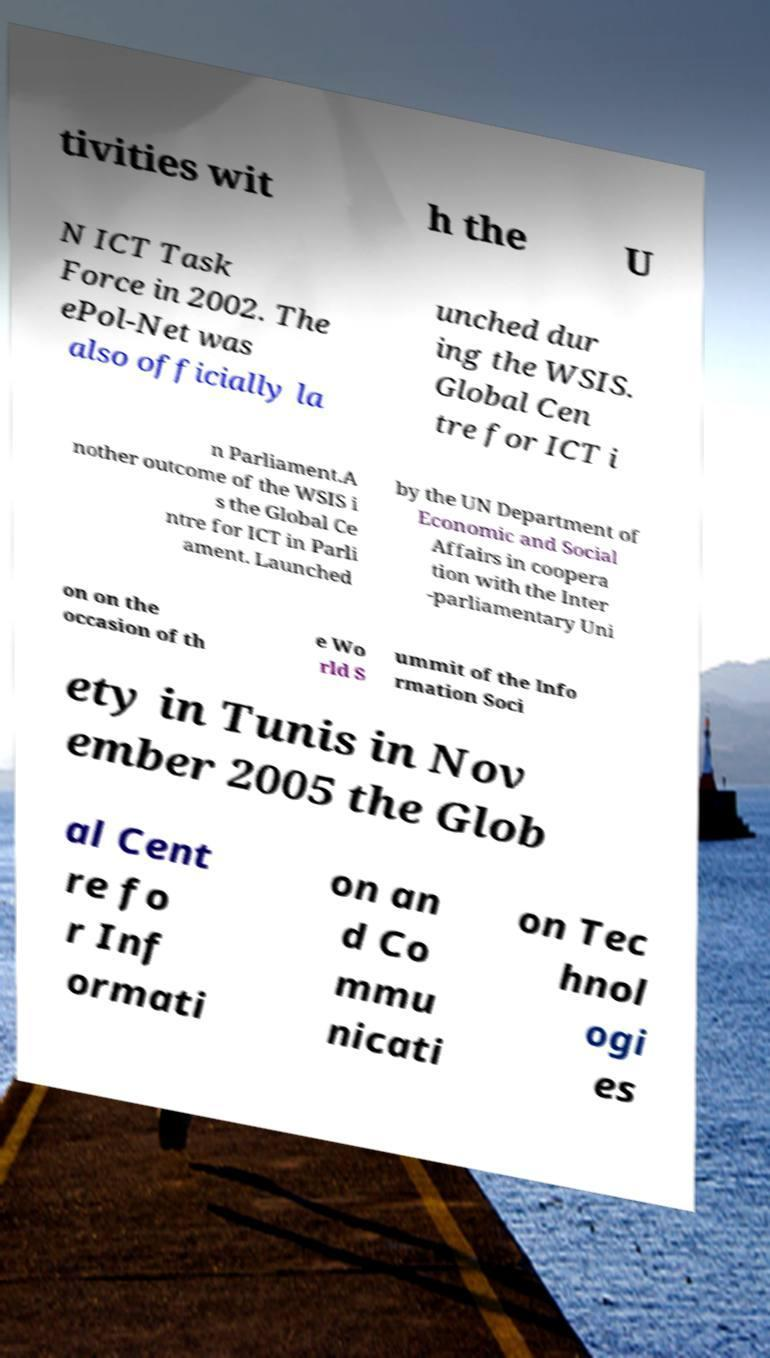There's text embedded in this image that I need extracted. Can you transcribe it verbatim? tivities wit h the U N ICT Task Force in 2002. The ePol-Net was also officially la unched dur ing the WSIS. Global Cen tre for ICT i n Parliament.A nother outcome of the WSIS i s the Global Ce ntre for ICT in Parli ament. Launched by the UN Department of Economic and Social Affairs in coopera tion with the Inter -parliamentary Uni on on the occasion of th e Wo rld S ummit of the Info rmation Soci ety in Tunis in Nov ember 2005 the Glob al Cent re fo r Inf ormati on an d Co mmu nicati on Tec hnol ogi es 